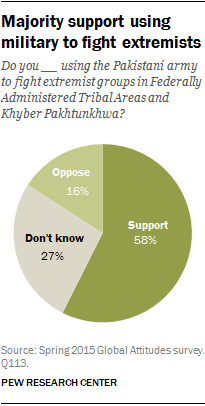Give some essential details in this illustration. There are two segments that have a green shade. The difference between the support and oppose segments is greater than the smallest segment, indicating a clear majority of users prefer the proposed solution. 